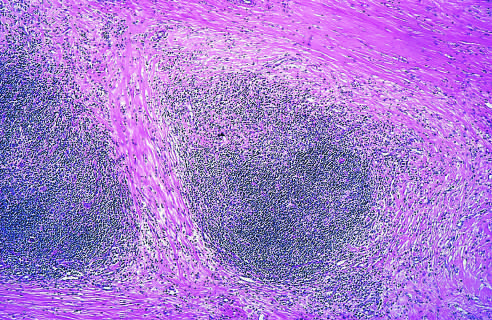does a low-power view show well-defined bands of pink, acellular collagen that have subdivided the tumor cells into nodules?
Answer the question using a single word or phrase. Yes 